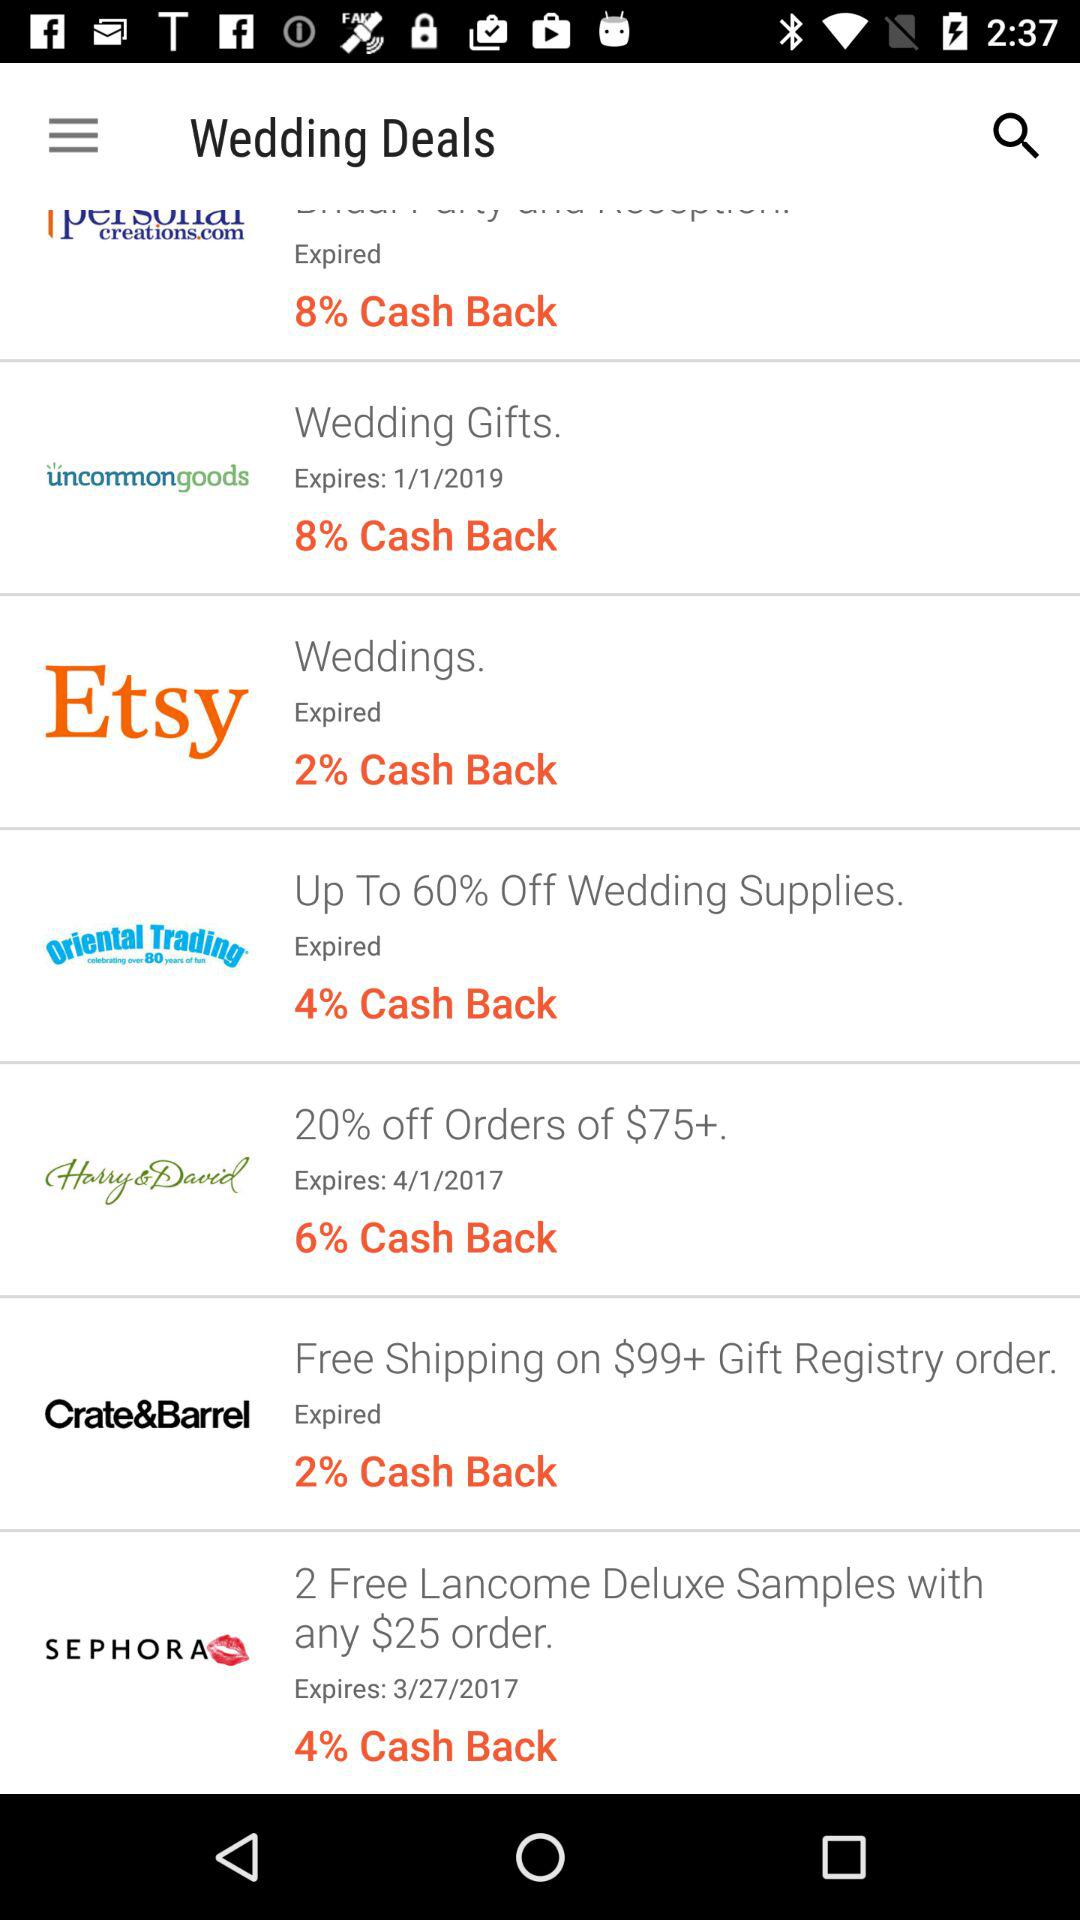When will "Wedding gifts" cashback expire? Cashback will expire on January 1st, 2019. 